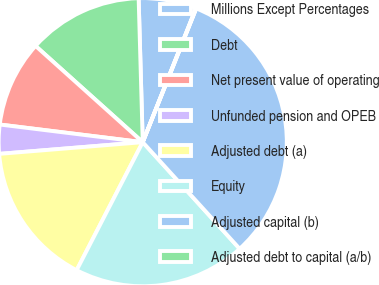<chart> <loc_0><loc_0><loc_500><loc_500><pie_chart><fcel>Millions Except Percentages<fcel>Debt<fcel>Net present value of operating<fcel>Unfunded pension and OPEB<fcel>Adjusted debt (a)<fcel>Equity<fcel>Adjusted capital (b)<fcel>Adjusted debt to capital (a/b)<nl><fcel>6.47%<fcel>12.9%<fcel>9.69%<fcel>3.25%<fcel>16.12%<fcel>19.33%<fcel>32.2%<fcel>0.04%<nl></chart> 